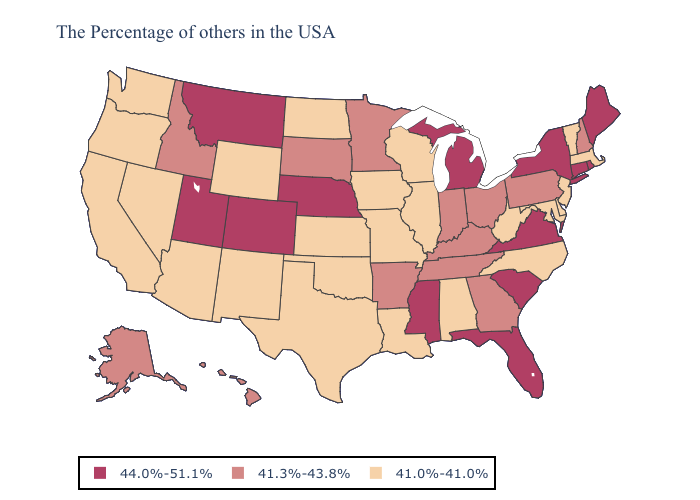What is the value of Wisconsin?
Give a very brief answer. 41.0%-41.0%. Which states hav the highest value in the South?
Write a very short answer. Virginia, South Carolina, Florida, Mississippi. Among the states that border Arkansas , does Oklahoma have the lowest value?
Keep it brief. Yes. Does Connecticut have the highest value in the USA?
Concise answer only. Yes. Which states have the highest value in the USA?
Give a very brief answer. Maine, Rhode Island, Connecticut, New York, Virginia, South Carolina, Florida, Michigan, Mississippi, Nebraska, Colorado, Utah, Montana. What is the value of Wyoming?
Give a very brief answer. 41.0%-41.0%. Name the states that have a value in the range 44.0%-51.1%?
Give a very brief answer. Maine, Rhode Island, Connecticut, New York, Virginia, South Carolina, Florida, Michigan, Mississippi, Nebraska, Colorado, Utah, Montana. What is the value of Kentucky?
Give a very brief answer. 41.3%-43.8%. Does the map have missing data?
Give a very brief answer. No. What is the value of New Hampshire?
Answer briefly. 41.3%-43.8%. What is the lowest value in the USA?
Concise answer only. 41.0%-41.0%. Does Kentucky have the same value as Pennsylvania?
Write a very short answer. Yes. Does Pennsylvania have a higher value than Georgia?
Keep it brief. No. What is the value of Kentucky?
Answer briefly. 41.3%-43.8%. Name the states that have a value in the range 41.0%-41.0%?
Be succinct. Massachusetts, Vermont, New Jersey, Delaware, Maryland, North Carolina, West Virginia, Alabama, Wisconsin, Illinois, Louisiana, Missouri, Iowa, Kansas, Oklahoma, Texas, North Dakota, Wyoming, New Mexico, Arizona, Nevada, California, Washington, Oregon. 